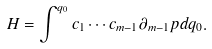<formula> <loc_0><loc_0><loc_500><loc_500>H = \int ^ { q _ { 0 } } c _ { 1 } \cdots c _ { m - 1 } \partial _ { m - 1 } p d q _ { 0 } .</formula> 